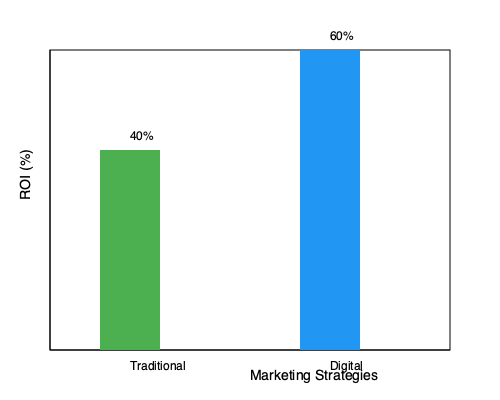Based on the bar graph comparing traditional and digital marketing strategies, which approach shows a higher Return on Investment (ROI), and by what percentage difference? To answer this question, we need to analyze the bar graph and follow these steps:

1. Identify the ROI percentages:
   - Traditional marketing: 40%
   - Digital marketing: 60%

2. Determine which strategy has a higher ROI:
   Digital marketing has a higher bar, indicating a higher ROI of 60% compared to traditional marketing's 40%.

3. Calculate the percentage difference:
   - Difference in ROI: $60% - 40% = 20%$
   
4. Express the result:
   Digital marketing shows a higher ROI, with a difference of 20 percentage points.

This comparison highlights the effectiveness of digital marketing strategies in the modern era, which aligns with the persona of a marketing professional bringing modern perspectives to traditional views.
Answer: Digital marketing, 20% higher 